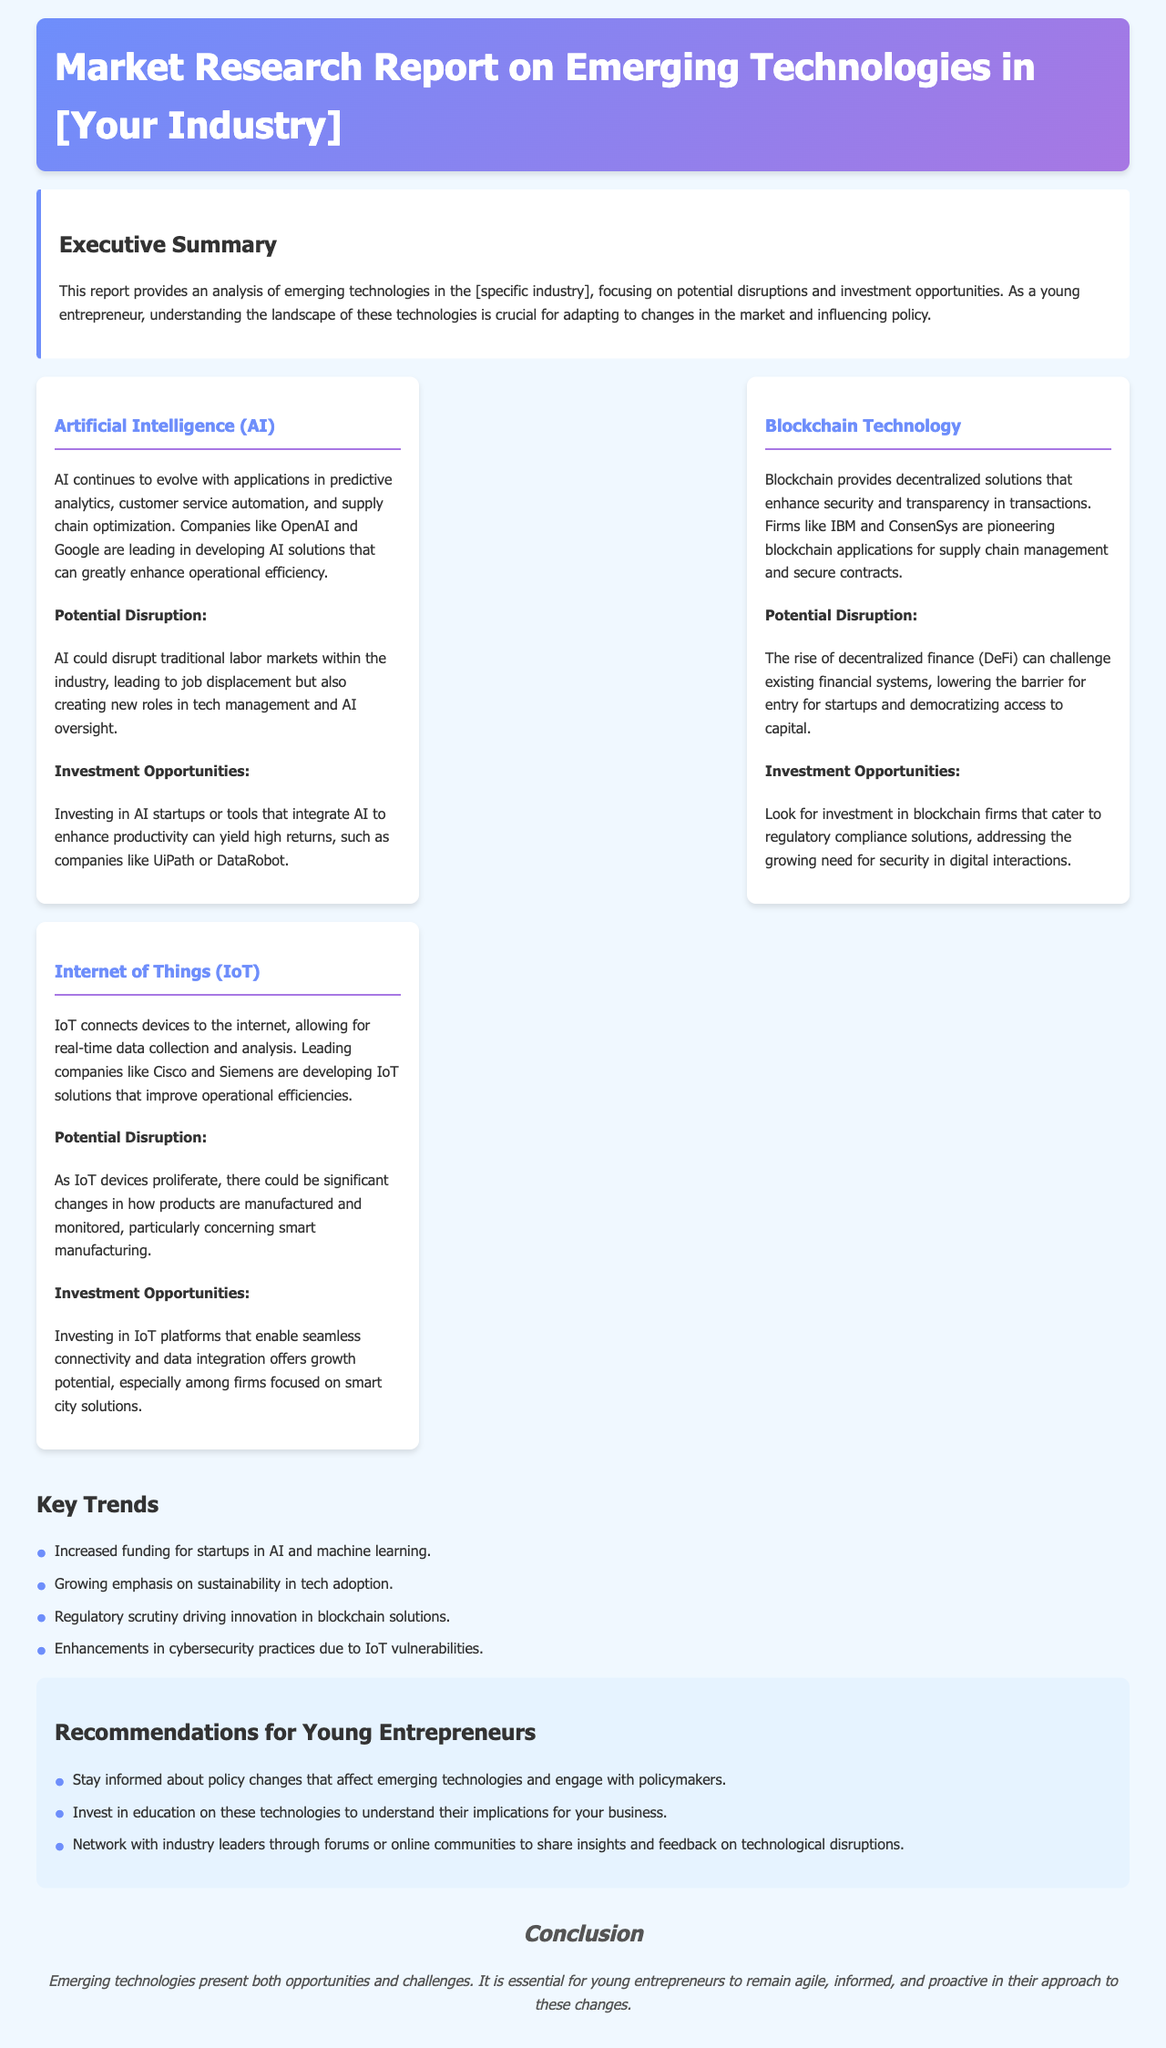What is the title of the report? The title of the report is stated in the header section.
Answer: Market Research Report on Emerging Technologies in [Your Industry] Who is leading in developing AI solutions? The document mentions specific companies leading in AI solutions.
Answer: OpenAI and Google What technology connects devices to the internet? This information can be found in the IoT technology section.
Answer: Internet of Things (IoT) What are the potential disruptions of Blockchain Technology? The potential disruption for Blockchain Technology is explained in the corresponding section.
Answer: The rise of decentralized finance (DeFi) What investment opportunity is associated with AI? The investment opportunities for AI are detailed in the AI section.
Answer: Investing in AI startups or tools What is a key trend mentioned in the report? The report lists various key trends in a section.
Answer: Increased funding for startups in AI and machine learning What should young entrepreneurs do regarding policy changes? Recommendations for young entrepreneurs are provided for interacting with policy.
Answer: Engage with policymakers What is the conclusion about emerging technologies? The conclusion summarizes the overall perspective on emerging technologies.
Answer: Present both opportunities and challenges 